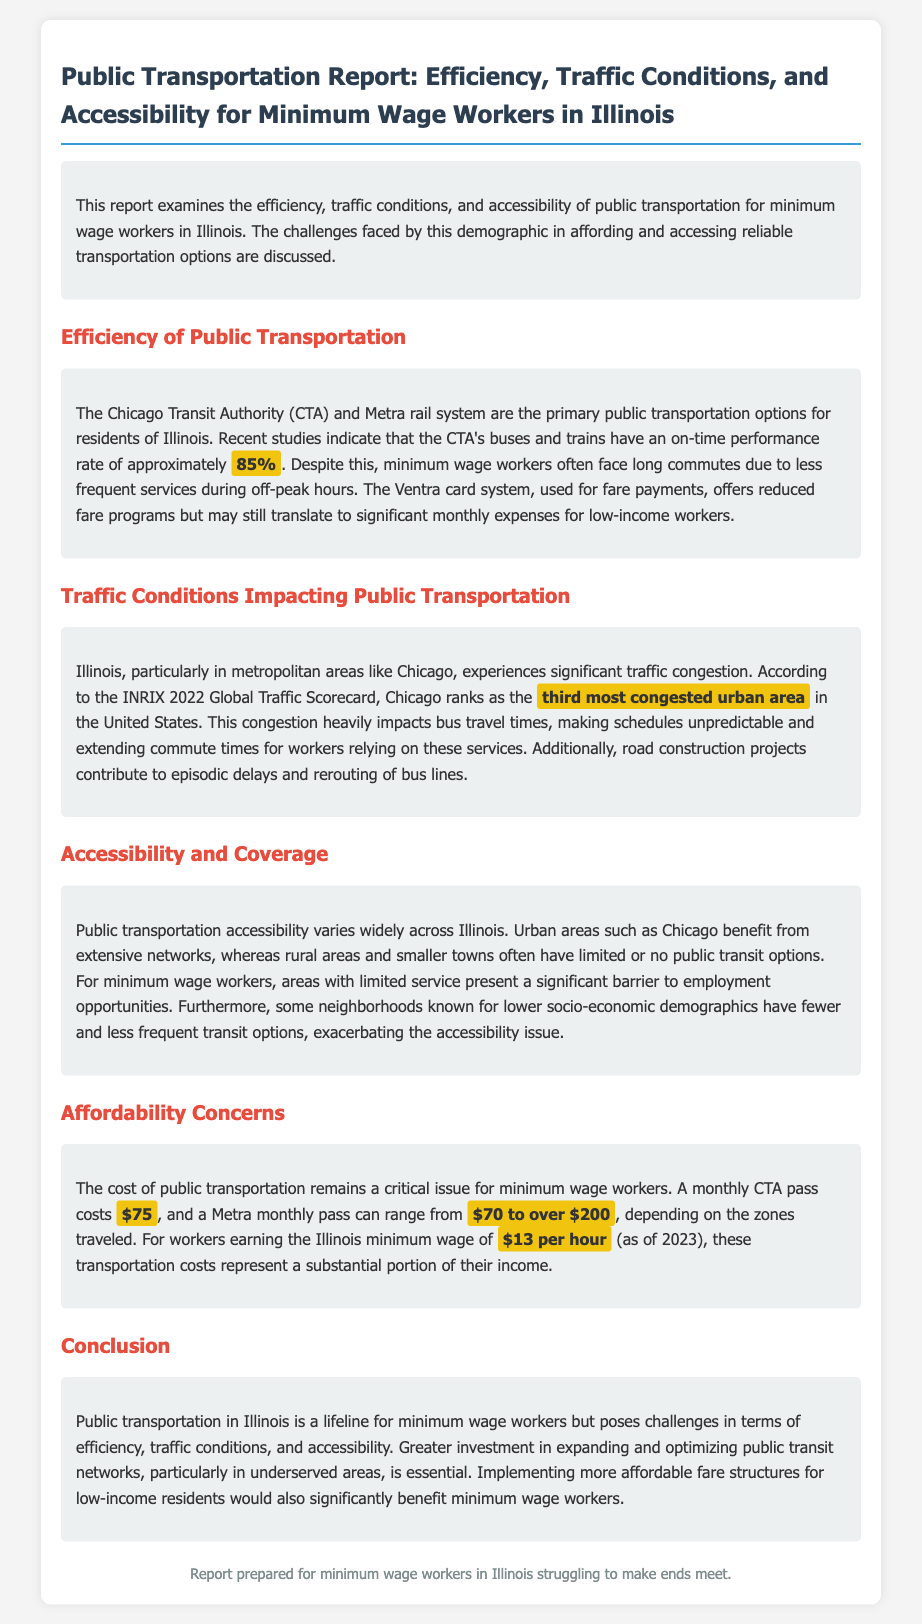What is the on-time performance rate of the CTA's services? The document states that the CTA's buses and trains have an on-time performance rate of approximately 85%.
Answer: 85% What does a monthly CTA pass cost? According to the report, a monthly CTA pass costs $75.
Answer: $75 Which city ranks as the third most congested urban area in the United States? The report indicates that Chicago ranks as the third most congested urban area in the United States.
Answer: Chicago What is the Illinois minimum wage as of 2023? The document mentions that the Illinois minimum wage is $13 per hour (as of 2023).
Answer: $13 per hour What is a significant barrier to employment opportunities for minimum wage workers in rural areas? The accessibility of public transportation varies widely, and in rural areas, there are often limited or no public transit options.
Answer: Limited or no public transit options What is a contributing factor to unpredictable bus travel times? Traffic congestion heavily impacts bus travel times, according to the document.
Answer: Traffic congestion How much can a Metra monthly pass cost? The report states that a Metra monthly pass can range from $70 to over $200, depending on the zones traveled.
Answer: $70 to over $200 What is suggested as essential for improving public transportation for minimum wage workers? The conclusion emphasizes the need for greater investment in expanding and optimizing public transit networks.
Answer: Greater investment in expanding and optimizing public transit networks What issue does the Ventra card system address for low-income workers? The Ventra card system offers reduced fare programs, but transportation costs can still be significant for low-income workers.
Answer: Reduced fare programs 